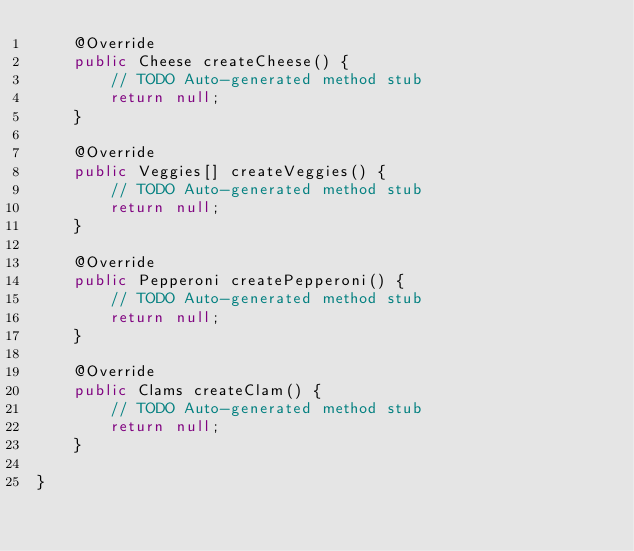Convert code to text. <code><loc_0><loc_0><loc_500><loc_500><_Java_>    @Override
    public Cheese createCheese() {
        // TODO Auto-generated method stub
        return null;
    }

    @Override
    public Veggies[] createVeggies() {
        // TODO Auto-generated method stub
        return null;
    }

    @Override
    public Pepperoni createPepperoni() {
        // TODO Auto-generated method stub
        return null;
    }

    @Override
    public Clams createClam() {
        // TODO Auto-generated method stub
        return null;
    }
    
}
</code> 